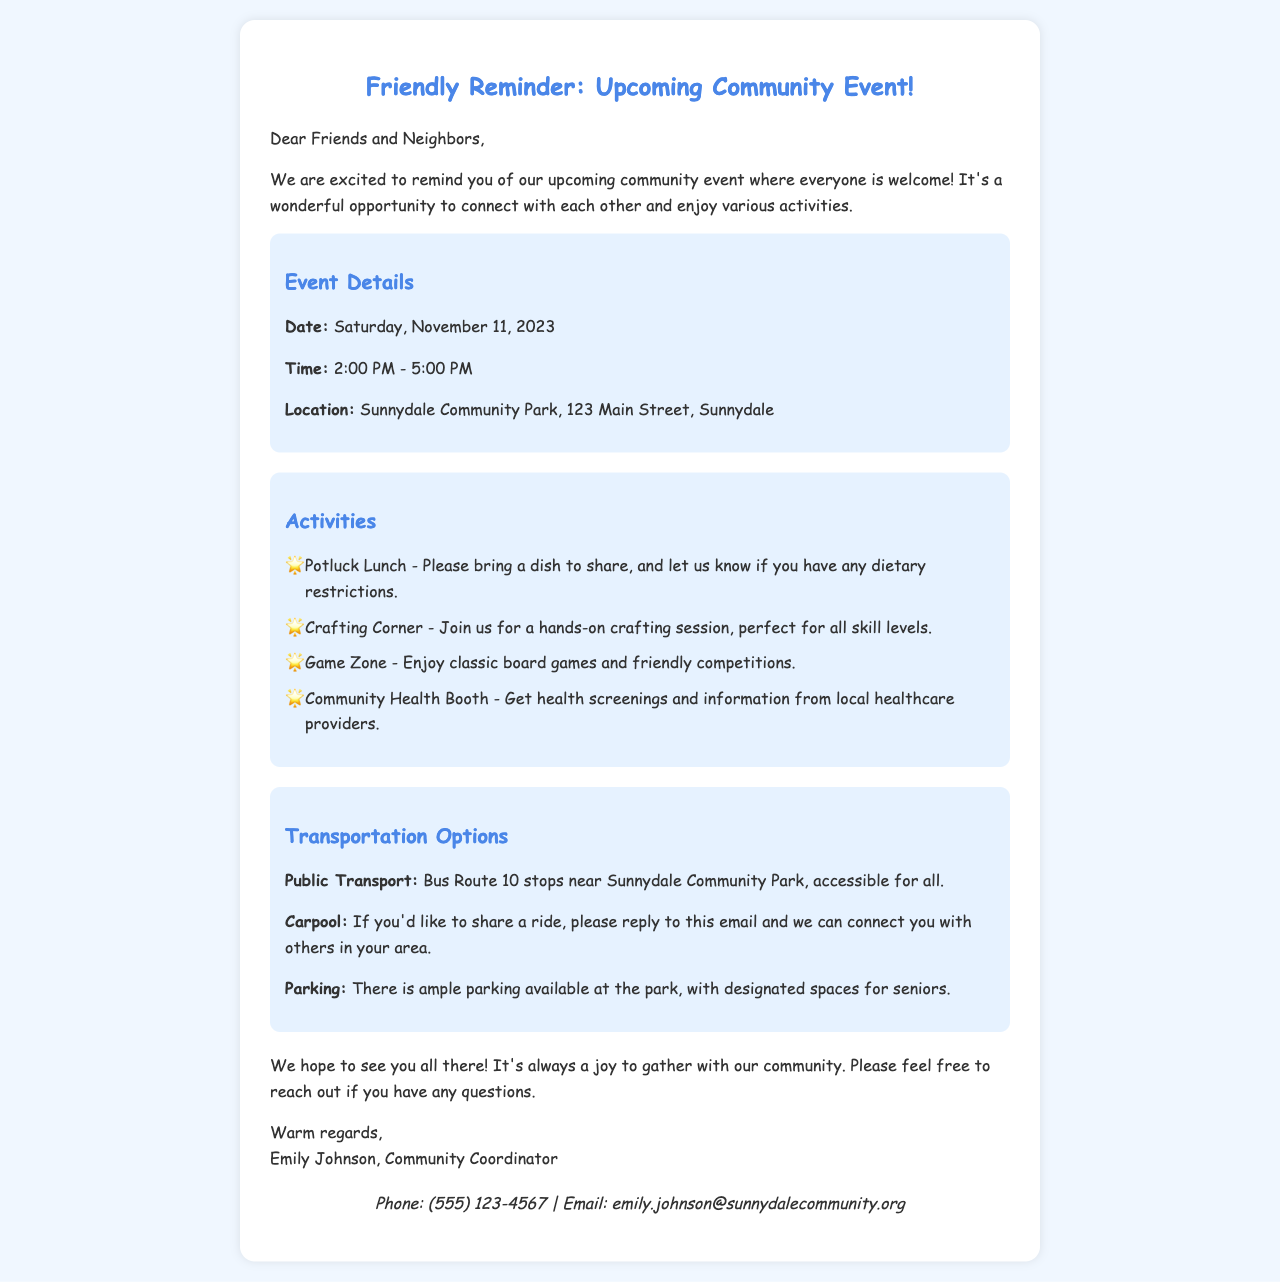What is the date of the community event? The date of the event is specified in the document, which is Saturday, November 11, 2023.
Answer: Saturday, November 11, 2023 What time does the event start? The starting time of the event is clearly mentioned, which is 2:00 PM.
Answer: 2:00 PM What is the location of the event? The document specifies the location of the event as Sunnydale Community Park, 123 Main Street, Sunnydale.
Answer: Sunnydale Community Park, 123 Main Street, Sunnydale What activities are available at the event? The document lists specific activities planned for the event, including a Potluck Lunch and Crafting Corner.
Answer: Potluck Lunch, Crafting Corner What transportation option is available for seniors? The document mentions designated parking spaces for seniors as part of the transportation options.
Answer: Designated spaces for seniors How can I arrange a carpool? The email suggests replying to the email to connect with others for carpooling.
Answer: Reply to this email Who is the contact person for the event? The document identifies Emily Johnson as the community coordinator responsible for the event.
Answer: Emily Johnson What type of event is being organized? The document refers to the gathering as a community event, inviting all members to join.
Answer: Community event 